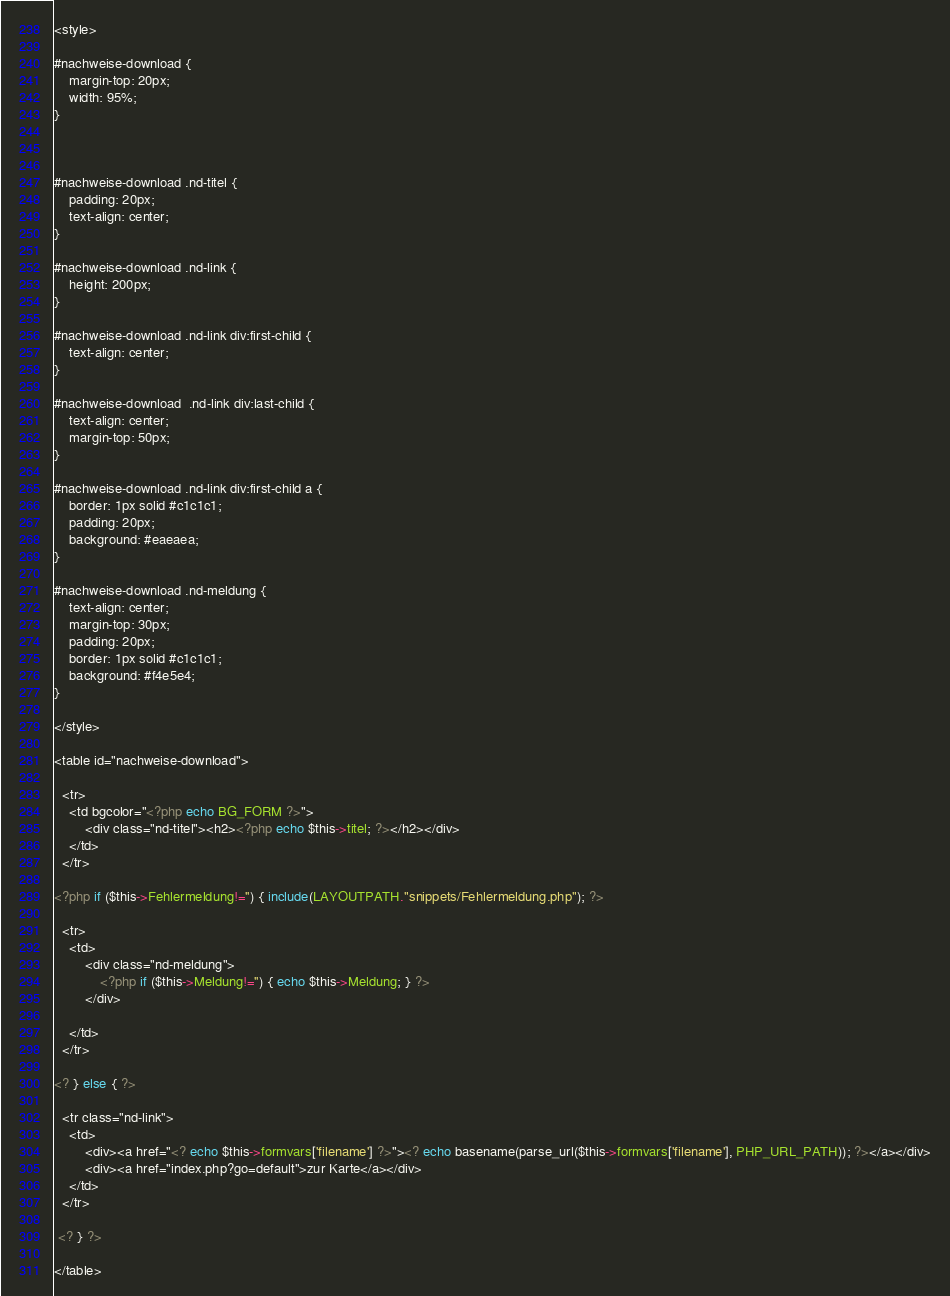<code> <loc_0><loc_0><loc_500><loc_500><_PHP_><style>

#nachweise-download {
	margin-top: 20px;
	width: 95%;
}

 

#nachweise-download .nd-titel {
	padding: 20px;
	text-align: center;
}

#nachweise-download .nd-link {
	height: 200px;
}

#nachweise-download .nd-link div:first-child {
	text-align: center;
}

#nachweise-download  .nd-link div:last-child {
	text-align: center;
	margin-top: 50px;
}

#nachweise-download .nd-link div:first-child a {
	border: 1px solid #c1c1c1;
	padding: 20px;
	background: #eaeaea;
}

#nachweise-download .nd-meldung {
	text-align: center;
	margin-top: 30px;
	padding: 20px;
	border: 1px solid #c1c1c1;
	background: #f4e5e4;
}

</style>

<table id="nachweise-download">

  <tr> 
    <td bgcolor="<?php echo BG_FORM ?>">
		<div class="nd-titel"><h2><?php echo $this->titel; ?></h2></div>
	</td>
  </tr>

<?php if ($this->Fehlermeldung!='') { include(LAYOUTPATH."snippets/Fehlermeldung.php"); ?>

  <tr> 
    <td>
		<div class="nd-meldung">
			<?php if ($this->Meldung!='') { echo $this->Meldung; } ?>
		</div>
	 
    </td>
  </tr>

<? } else { ?>

  <tr class="nd-link">
  	<td>
		<div><a href="<? echo $this->formvars['filename'] ?>"><? echo basename(parse_url($this->formvars['filename'], PHP_URL_PATH)); ?></a></div>
		<div><a href="index.php?go=default">zur Karte</a></div>
	</td>
  </tr>

 <? } ?>

</table></code> 